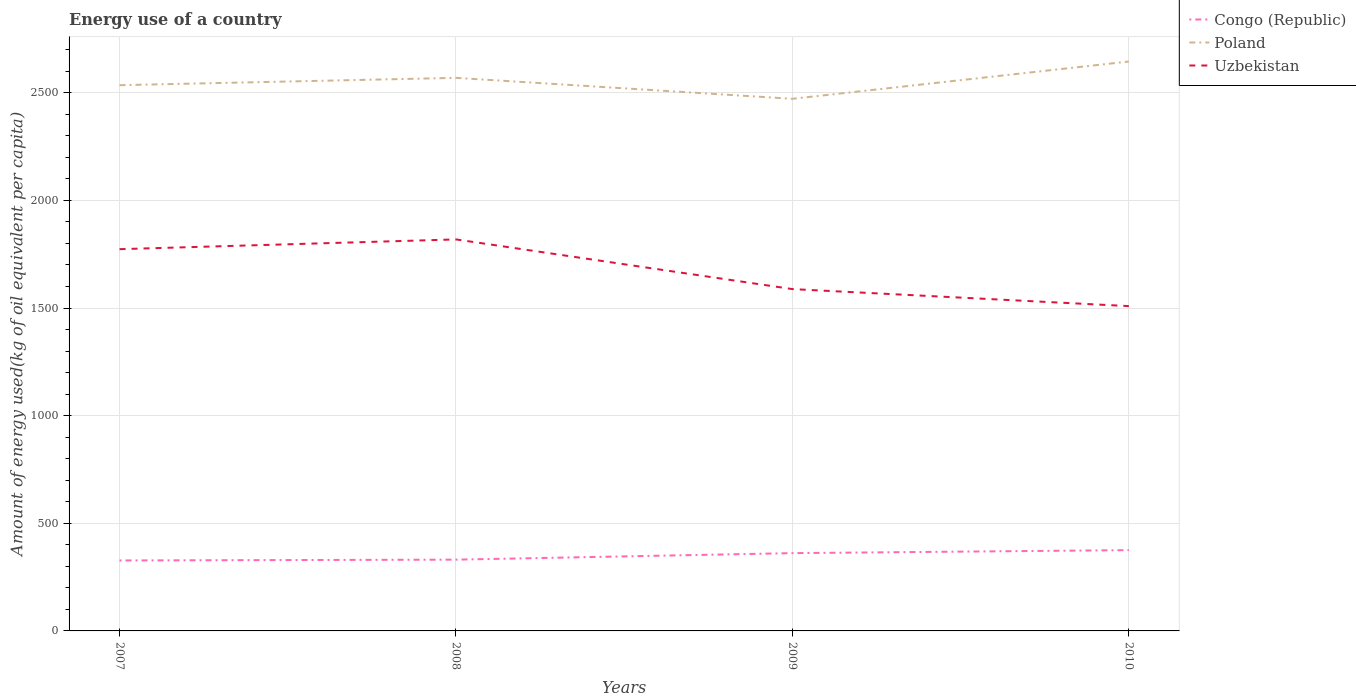Does the line corresponding to Poland intersect with the line corresponding to Congo (Republic)?
Keep it short and to the point. No. Is the number of lines equal to the number of legend labels?
Offer a very short reply. Yes. Across all years, what is the maximum amount of energy used in in Uzbekistan?
Your answer should be compact. 1508.86. In which year was the amount of energy used in in Poland maximum?
Provide a short and direct response. 2009. What is the total amount of energy used in in Congo (Republic) in the graph?
Offer a very short reply. -44.2. What is the difference between the highest and the second highest amount of energy used in in Uzbekistan?
Your answer should be compact. 309.79. What is the difference between the highest and the lowest amount of energy used in in Congo (Republic)?
Give a very brief answer. 2. How many years are there in the graph?
Make the answer very short. 4. Are the values on the major ticks of Y-axis written in scientific E-notation?
Offer a terse response. No. Does the graph contain any zero values?
Keep it short and to the point. No. Does the graph contain grids?
Your response must be concise. Yes. Where does the legend appear in the graph?
Give a very brief answer. Top right. How many legend labels are there?
Ensure brevity in your answer.  3. What is the title of the graph?
Make the answer very short. Energy use of a country. Does "Mauritius" appear as one of the legend labels in the graph?
Ensure brevity in your answer.  No. What is the label or title of the X-axis?
Your response must be concise. Years. What is the label or title of the Y-axis?
Give a very brief answer. Amount of energy used(kg of oil equivalent per capita). What is the Amount of energy used(kg of oil equivalent per capita) of Congo (Republic) in 2007?
Your answer should be very brief. 327.34. What is the Amount of energy used(kg of oil equivalent per capita) in Poland in 2007?
Provide a succinct answer. 2535.12. What is the Amount of energy used(kg of oil equivalent per capita) in Uzbekistan in 2007?
Offer a terse response. 1773.35. What is the Amount of energy used(kg of oil equivalent per capita) in Congo (Republic) in 2008?
Your answer should be compact. 331.06. What is the Amount of energy used(kg of oil equivalent per capita) of Poland in 2008?
Provide a succinct answer. 2569.22. What is the Amount of energy used(kg of oil equivalent per capita) of Uzbekistan in 2008?
Make the answer very short. 1818.65. What is the Amount of energy used(kg of oil equivalent per capita) in Congo (Republic) in 2009?
Make the answer very short. 361.4. What is the Amount of energy used(kg of oil equivalent per capita) in Poland in 2009?
Your answer should be compact. 2471.83. What is the Amount of energy used(kg of oil equivalent per capita) in Uzbekistan in 2009?
Provide a short and direct response. 1587.89. What is the Amount of energy used(kg of oil equivalent per capita) of Congo (Republic) in 2010?
Offer a terse response. 375.26. What is the Amount of energy used(kg of oil equivalent per capita) of Poland in 2010?
Make the answer very short. 2645.03. What is the Amount of energy used(kg of oil equivalent per capita) of Uzbekistan in 2010?
Ensure brevity in your answer.  1508.86. Across all years, what is the maximum Amount of energy used(kg of oil equivalent per capita) of Congo (Republic)?
Offer a very short reply. 375.26. Across all years, what is the maximum Amount of energy used(kg of oil equivalent per capita) of Poland?
Make the answer very short. 2645.03. Across all years, what is the maximum Amount of energy used(kg of oil equivalent per capita) in Uzbekistan?
Give a very brief answer. 1818.65. Across all years, what is the minimum Amount of energy used(kg of oil equivalent per capita) of Congo (Republic)?
Offer a very short reply. 327.34. Across all years, what is the minimum Amount of energy used(kg of oil equivalent per capita) of Poland?
Your response must be concise. 2471.83. Across all years, what is the minimum Amount of energy used(kg of oil equivalent per capita) of Uzbekistan?
Provide a short and direct response. 1508.86. What is the total Amount of energy used(kg of oil equivalent per capita) of Congo (Republic) in the graph?
Give a very brief answer. 1395.06. What is the total Amount of energy used(kg of oil equivalent per capita) in Poland in the graph?
Your response must be concise. 1.02e+04. What is the total Amount of energy used(kg of oil equivalent per capita) in Uzbekistan in the graph?
Offer a terse response. 6688.74. What is the difference between the Amount of energy used(kg of oil equivalent per capita) of Congo (Republic) in 2007 and that in 2008?
Give a very brief answer. -3.71. What is the difference between the Amount of energy used(kg of oil equivalent per capita) of Poland in 2007 and that in 2008?
Offer a very short reply. -34.09. What is the difference between the Amount of energy used(kg of oil equivalent per capita) of Uzbekistan in 2007 and that in 2008?
Provide a short and direct response. -45.3. What is the difference between the Amount of energy used(kg of oil equivalent per capita) of Congo (Republic) in 2007 and that in 2009?
Make the answer very short. -34.06. What is the difference between the Amount of energy used(kg of oil equivalent per capita) in Poland in 2007 and that in 2009?
Provide a short and direct response. 63.29. What is the difference between the Amount of energy used(kg of oil equivalent per capita) of Uzbekistan in 2007 and that in 2009?
Give a very brief answer. 185.45. What is the difference between the Amount of energy used(kg of oil equivalent per capita) of Congo (Republic) in 2007 and that in 2010?
Make the answer very short. -47.91. What is the difference between the Amount of energy used(kg of oil equivalent per capita) of Poland in 2007 and that in 2010?
Keep it short and to the point. -109.9. What is the difference between the Amount of energy used(kg of oil equivalent per capita) in Uzbekistan in 2007 and that in 2010?
Provide a succinct answer. 264.49. What is the difference between the Amount of energy used(kg of oil equivalent per capita) in Congo (Republic) in 2008 and that in 2009?
Ensure brevity in your answer.  -30.34. What is the difference between the Amount of energy used(kg of oil equivalent per capita) of Poland in 2008 and that in 2009?
Provide a succinct answer. 97.39. What is the difference between the Amount of energy used(kg of oil equivalent per capita) of Uzbekistan in 2008 and that in 2009?
Ensure brevity in your answer.  230.75. What is the difference between the Amount of energy used(kg of oil equivalent per capita) of Congo (Republic) in 2008 and that in 2010?
Your response must be concise. -44.2. What is the difference between the Amount of energy used(kg of oil equivalent per capita) of Poland in 2008 and that in 2010?
Offer a very short reply. -75.81. What is the difference between the Amount of energy used(kg of oil equivalent per capita) in Uzbekistan in 2008 and that in 2010?
Give a very brief answer. 309.79. What is the difference between the Amount of energy used(kg of oil equivalent per capita) of Congo (Republic) in 2009 and that in 2010?
Offer a very short reply. -13.85. What is the difference between the Amount of energy used(kg of oil equivalent per capita) of Poland in 2009 and that in 2010?
Offer a very short reply. -173.2. What is the difference between the Amount of energy used(kg of oil equivalent per capita) in Uzbekistan in 2009 and that in 2010?
Offer a very short reply. 79.04. What is the difference between the Amount of energy used(kg of oil equivalent per capita) of Congo (Republic) in 2007 and the Amount of energy used(kg of oil equivalent per capita) of Poland in 2008?
Your answer should be compact. -2241.87. What is the difference between the Amount of energy used(kg of oil equivalent per capita) of Congo (Republic) in 2007 and the Amount of energy used(kg of oil equivalent per capita) of Uzbekistan in 2008?
Provide a short and direct response. -1491.3. What is the difference between the Amount of energy used(kg of oil equivalent per capita) of Poland in 2007 and the Amount of energy used(kg of oil equivalent per capita) of Uzbekistan in 2008?
Your response must be concise. 716.48. What is the difference between the Amount of energy used(kg of oil equivalent per capita) in Congo (Republic) in 2007 and the Amount of energy used(kg of oil equivalent per capita) in Poland in 2009?
Ensure brevity in your answer.  -2144.49. What is the difference between the Amount of energy used(kg of oil equivalent per capita) in Congo (Republic) in 2007 and the Amount of energy used(kg of oil equivalent per capita) in Uzbekistan in 2009?
Your answer should be compact. -1260.55. What is the difference between the Amount of energy used(kg of oil equivalent per capita) in Poland in 2007 and the Amount of energy used(kg of oil equivalent per capita) in Uzbekistan in 2009?
Provide a succinct answer. 947.23. What is the difference between the Amount of energy used(kg of oil equivalent per capita) of Congo (Republic) in 2007 and the Amount of energy used(kg of oil equivalent per capita) of Poland in 2010?
Provide a succinct answer. -2317.68. What is the difference between the Amount of energy used(kg of oil equivalent per capita) in Congo (Republic) in 2007 and the Amount of energy used(kg of oil equivalent per capita) in Uzbekistan in 2010?
Keep it short and to the point. -1181.51. What is the difference between the Amount of energy used(kg of oil equivalent per capita) of Poland in 2007 and the Amount of energy used(kg of oil equivalent per capita) of Uzbekistan in 2010?
Provide a short and direct response. 1026.27. What is the difference between the Amount of energy used(kg of oil equivalent per capita) in Congo (Republic) in 2008 and the Amount of energy used(kg of oil equivalent per capita) in Poland in 2009?
Your response must be concise. -2140.77. What is the difference between the Amount of energy used(kg of oil equivalent per capita) in Congo (Republic) in 2008 and the Amount of energy used(kg of oil equivalent per capita) in Uzbekistan in 2009?
Offer a terse response. -1256.83. What is the difference between the Amount of energy used(kg of oil equivalent per capita) of Poland in 2008 and the Amount of energy used(kg of oil equivalent per capita) of Uzbekistan in 2009?
Provide a succinct answer. 981.33. What is the difference between the Amount of energy used(kg of oil equivalent per capita) in Congo (Republic) in 2008 and the Amount of energy used(kg of oil equivalent per capita) in Poland in 2010?
Your response must be concise. -2313.97. What is the difference between the Amount of energy used(kg of oil equivalent per capita) of Congo (Republic) in 2008 and the Amount of energy used(kg of oil equivalent per capita) of Uzbekistan in 2010?
Offer a very short reply. -1177.8. What is the difference between the Amount of energy used(kg of oil equivalent per capita) of Poland in 2008 and the Amount of energy used(kg of oil equivalent per capita) of Uzbekistan in 2010?
Ensure brevity in your answer.  1060.36. What is the difference between the Amount of energy used(kg of oil equivalent per capita) in Congo (Republic) in 2009 and the Amount of energy used(kg of oil equivalent per capita) in Poland in 2010?
Your answer should be very brief. -2283.63. What is the difference between the Amount of energy used(kg of oil equivalent per capita) of Congo (Republic) in 2009 and the Amount of energy used(kg of oil equivalent per capita) of Uzbekistan in 2010?
Ensure brevity in your answer.  -1147.45. What is the difference between the Amount of energy used(kg of oil equivalent per capita) of Poland in 2009 and the Amount of energy used(kg of oil equivalent per capita) of Uzbekistan in 2010?
Offer a very short reply. 962.98. What is the average Amount of energy used(kg of oil equivalent per capita) of Congo (Republic) per year?
Make the answer very short. 348.76. What is the average Amount of energy used(kg of oil equivalent per capita) of Poland per year?
Ensure brevity in your answer.  2555.3. What is the average Amount of energy used(kg of oil equivalent per capita) in Uzbekistan per year?
Your answer should be compact. 1672.18. In the year 2007, what is the difference between the Amount of energy used(kg of oil equivalent per capita) in Congo (Republic) and Amount of energy used(kg of oil equivalent per capita) in Poland?
Your answer should be compact. -2207.78. In the year 2007, what is the difference between the Amount of energy used(kg of oil equivalent per capita) of Congo (Republic) and Amount of energy used(kg of oil equivalent per capita) of Uzbekistan?
Your answer should be compact. -1446. In the year 2007, what is the difference between the Amount of energy used(kg of oil equivalent per capita) of Poland and Amount of energy used(kg of oil equivalent per capita) of Uzbekistan?
Your answer should be compact. 761.78. In the year 2008, what is the difference between the Amount of energy used(kg of oil equivalent per capita) of Congo (Republic) and Amount of energy used(kg of oil equivalent per capita) of Poland?
Offer a terse response. -2238.16. In the year 2008, what is the difference between the Amount of energy used(kg of oil equivalent per capita) of Congo (Republic) and Amount of energy used(kg of oil equivalent per capita) of Uzbekistan?
Keep it short and to the point. -1487.59. In the year 2008, what is the difference between the Amount of energy used(kg of oil equivalent per capita) of Poland and Amount of energy used(kg of oil equivalent per capita) of Uzbekistan?
Make the answer very short. 750.57. In the year 2009, what is the difference between the Amount of energy used(kg of oil equivalent per capita) in Congo (Republic) and Amount of energy used(kg of oil equivalent per capita) in Poland?
Offer a very short reply. -2110.43. In the year 2009, what is the difference between the Amount of energy used(kg of oil equivalent per capita) of Congo (Republic) and Amount of energy used(kg of oil equivalent per capita) of Uzbekistan?
Your response must be concise. -1226.49. In the year 2009, what is the difference between the Amount of energy used(kg of oil equivalent per capita) of Poland and Amount of energy used(kg of oil equivalent per capita) of Uzbekistan?
Keep it short and to the point. 883.94. In the year 2010, what is the difference between the Amount of energy used(kg of oil equivalent per capita) of Congo (Republic) and Amount of energy used(kg of oil equivalent per capita) of Poland?
Your answer should be very brief. -2269.77. In the year 2010, what is the difference between the Amount of energy used(kg of oil equivalent per capita) of Congo (Republic) and Amount of energy used(kg of oil equivalent per capita) of Uzbekistan?
Offer a terse response. -1133.6. In the year 2010, what is the difference between the Amount of energy used(kg of oil equivalent per capita) of Poland and Amount of energy used(kg of oil equivalent per capita) of Uzbekistan?
Offer a very short reply. 1136.17. What is the ratio of the Amount of energy used(kg of oil equivalent per capita) in Congo (Republic) in 2007 to that in 2008?
Your response must be concise. 0.99. What is the ratio of the Amount of energy used(kg of oil equivalent per capita) in Poland in 2007 to that in 2008?
Provide a succinct answer. 0.99. What is the ratio of the Amount of energy used(kg of oil equivalent per capita) of Uzbekistan in 2007 to that in 2008?
Give a very brief answer. 0.98. What is the ratio of the Amount of energy used(kg of oil equivalent per capita) in Congo (Republic) in 2007 to that in 2009?
Offer a terse response. 0.91. What is the ratio of the Amount of energy used(kg of oil equivalent per capita) of Poland in 2007 to that in 2009?
Provide a short and direct response. 1.03. What is the ratio of the Amount of energy used(kg of oil equivalent per capita) of Uzbekistan in 2007 to that in 2009?
Ensure brevity in your answer.  1.12. What is the ratio of the Amount of energy used(kg of oil equivalent per capita) of Congo (Republic) in 2007 to that in 2010?
Ensure brevity in your answer.  0.87. What is the ratio of the Amount of energy used(kg of oil equivalent per capita) of Poland in 2007 to that in 2010?
Your answer should be very brief. 0.96. What is the ratio of the Amount of energy used(kg of oil equivalent per capita) in Uzbekistan in 2007 to that in 2010?
Provide a short and direct response. 1.18. What is the ratio of the Amount of energy used(kg of oil equivalent per capita) in Congo (Republic) in 2008 to that in 2009?
Give a very brief answer. 0.92. What is the ratio of the Amount of energy used(kg of oil equivalent per capita) of Poland in 2008 to that in 2009?
Your response must be concise. 1.04. What is the ratio of the Amount of energy used(kg of oil equivalent per capita) of Uzbekistan in 2008 to that in 2009?
Your response must be concise. 1.15. What is the ratio of the Amount of energy used(kg of oil equivalent per capita) of Congo (Republic) in 2008 to that in 2010?
Offer a very short reply. 0.88. What is the ratio of the Amount of energy used(kg of oil equivalent per capita) of Poland in 2008 to that in 2010?
Keep it short and to the point. 0.97. What is the ratio of the Amount of energy used(kg of oil equivalent per capita) of Uzbekistan in 2008 to that in 2010?
Your answer should be compact. 1.21. What is the ratio of the Amount of energy used(kg of oil equivalent per capita) in Congo (Republic) in 2009 to that in 2010?
Your answer should be very brief. 0.96. What is the ratio of the Amount of energy used(kg of oil equivalent per capita) of Poland in 2009 to that in 2010?
Ensure brevity in your answer.  0.93. What is the ratio of the Amount of energy used(kg of oil equivalent per capita) of Uzbekistan in 2009 to that in 2010?
Your answer should be compact. 1.05. What is the difference between the highest and the second highest Amount of energy used(kg of oil equivalent per capita) in Congo (Republic)?
Provide a succinct answer. 13.85. What is the difference between the highest and the second highest Amount of energy used(kg of oil equivalent per capita) of Poland?
Ensure brevity in your answer.  75.81. What is the difference between the highest and the second highest Amount of energy used(kg of oil equivalent per capita) in Uzbekistan?
Your answer should be very brief. 45.3. What is the difference between the highest and the lowest Amount of energy used(kg of oil equivalent per capita) of Congo (Republic)?
Your answer should be compact. 47.91. What is the difference between the highest and the lowest Amount of energy used(kg of oil equivalent per capita) in Poland?
Your answer should be very brief. 173.2. What is the difference between the highest and the lowest Amount of energy used(kg of oil equivalent per capita) of Uzbekistan?
Provide a short and direct response. 309.79. 